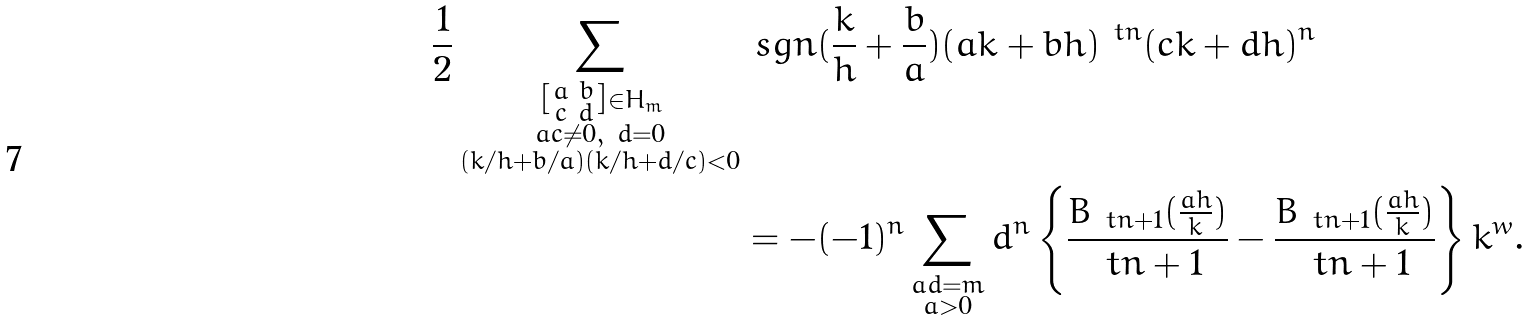<formula> <loc_0><loc_0><loc_500><loc_500>\frac { 1 } { 2 } \sum _ { \substack { \left [ \begin{smallmatrix} a & b \\ c & d \end{smallmatrix} \right ] \in H _ { m } \\ a c \ne 0 , \ d = 0 \\ ( k / h + b / a ) ( k / h + d / c ) < 0 } } & \ s g n ( \frac { k } { h } + \frac { b } { a } ) ( a k + b h ) ^ { \ t n } ( c k + d h ) ^ { n } \\ & = - ( - 1 ) ^ { n } \sum _ { \substack { a d = m \\ a > 0 } } d ^ { n } \left \{ \frac { B _ { \ t n + 1 } ( \frac { a h } { k } ) } { \ t n + 1 } - \frac { \bar { B } _ { \ t n + 1 } ( \frac { a h } { k } ) } { \ t n + 1 } \right \} k ^ { w } .</formula> 